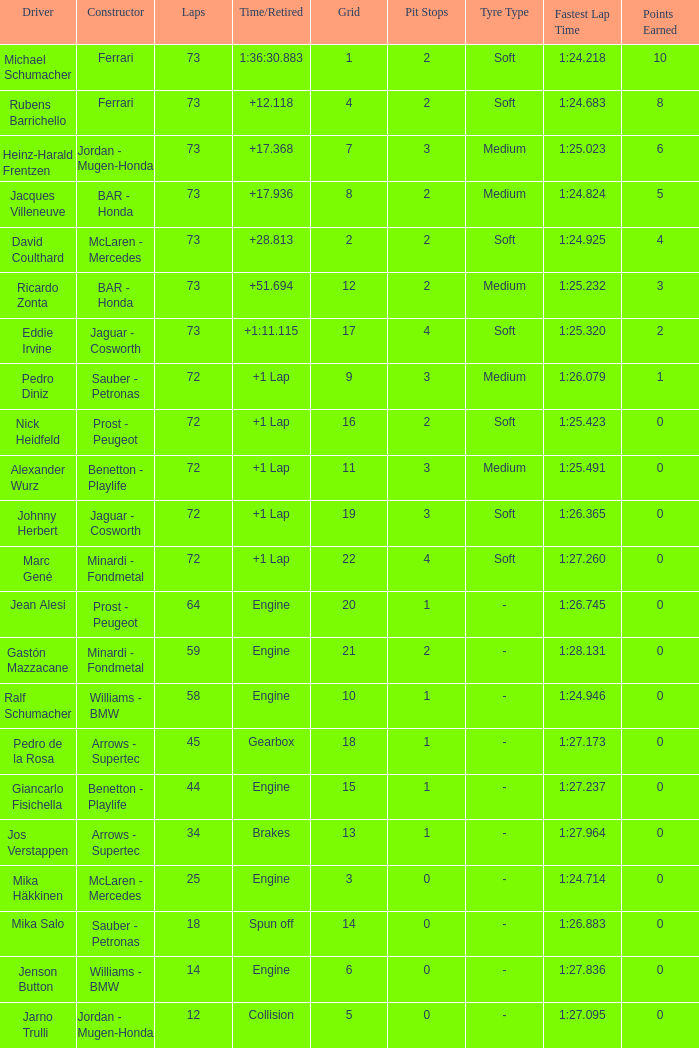How many laps did Giancarlo Fisichella do with a grid larger than 15? 0.0. 